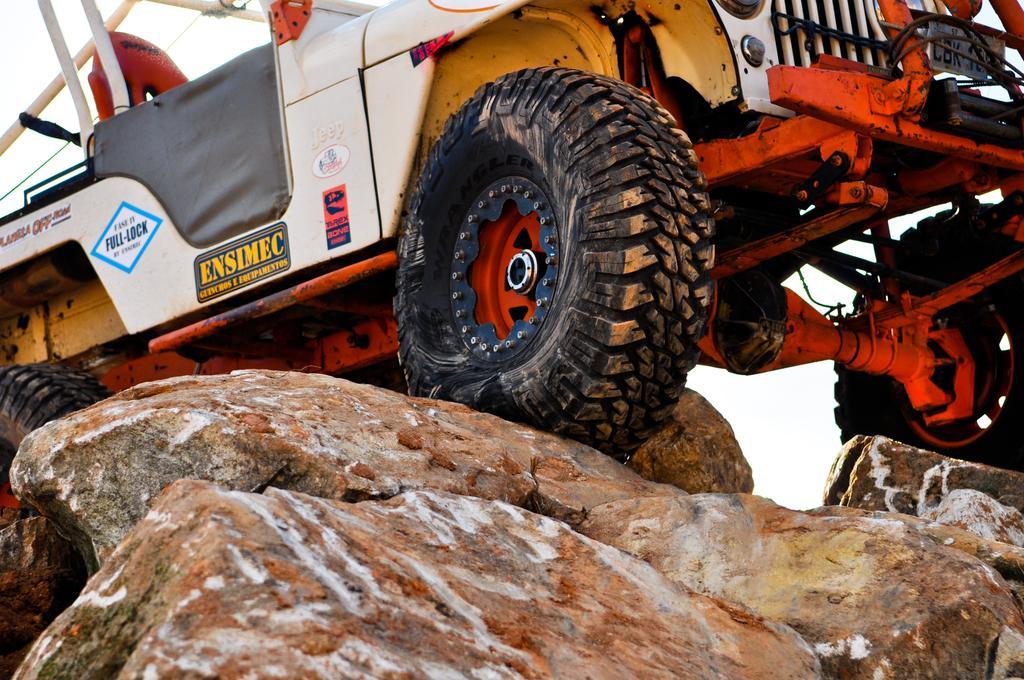Describe this image in one or two sentences. There is a vehicle kept on the rocks,it is an open top vehicle. 